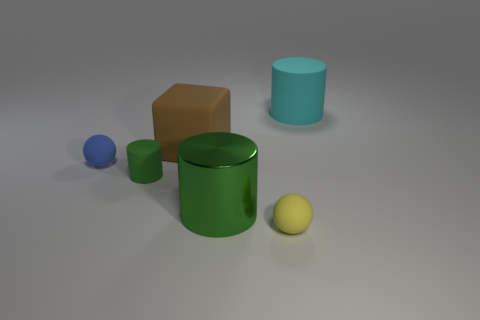Subtract all matte cylinders. How many cylinders are left? 1 Add 3 blue spheres. How many objects exist? 9 Subtract all cubes. How many objects are left? 5 Add 6 small green rubber objects. How many small green rubber objects exist? 7 Subtract 1 yellow spheres. How many objects are left? 5 Subtract all large cyan cylinders. Subtract all large red matte cylinders. How many objects are left? 5 Add 6 large rubber objects. How many large rubber objects are left? 8 